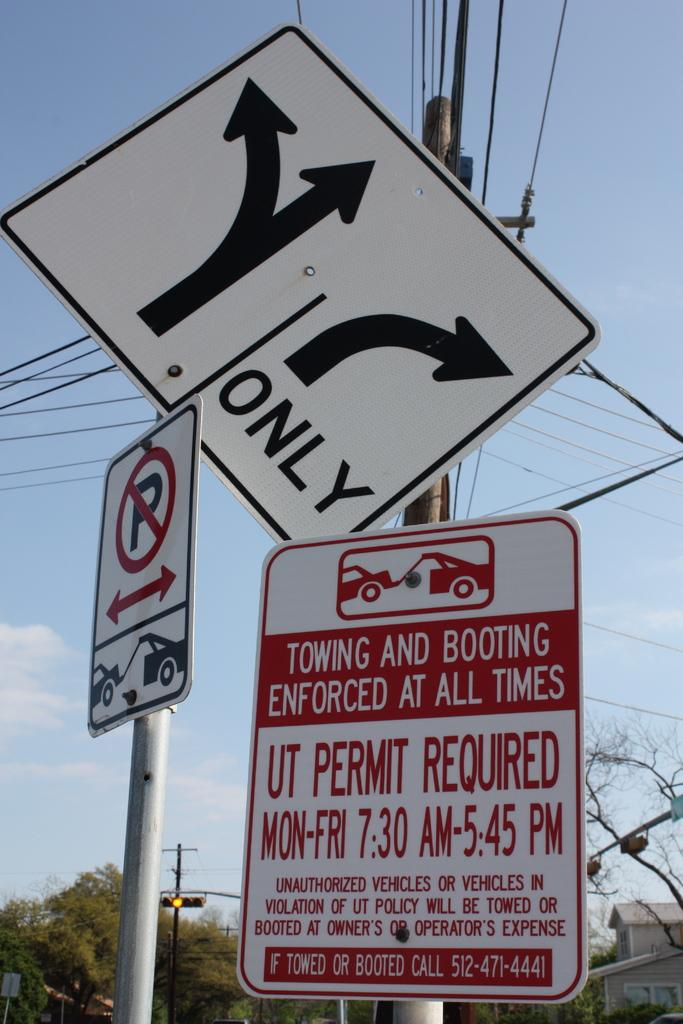<image>
Summarize the visual content of the image. Sign that says "Towing and Booting Enforced at All Times" near the top. 